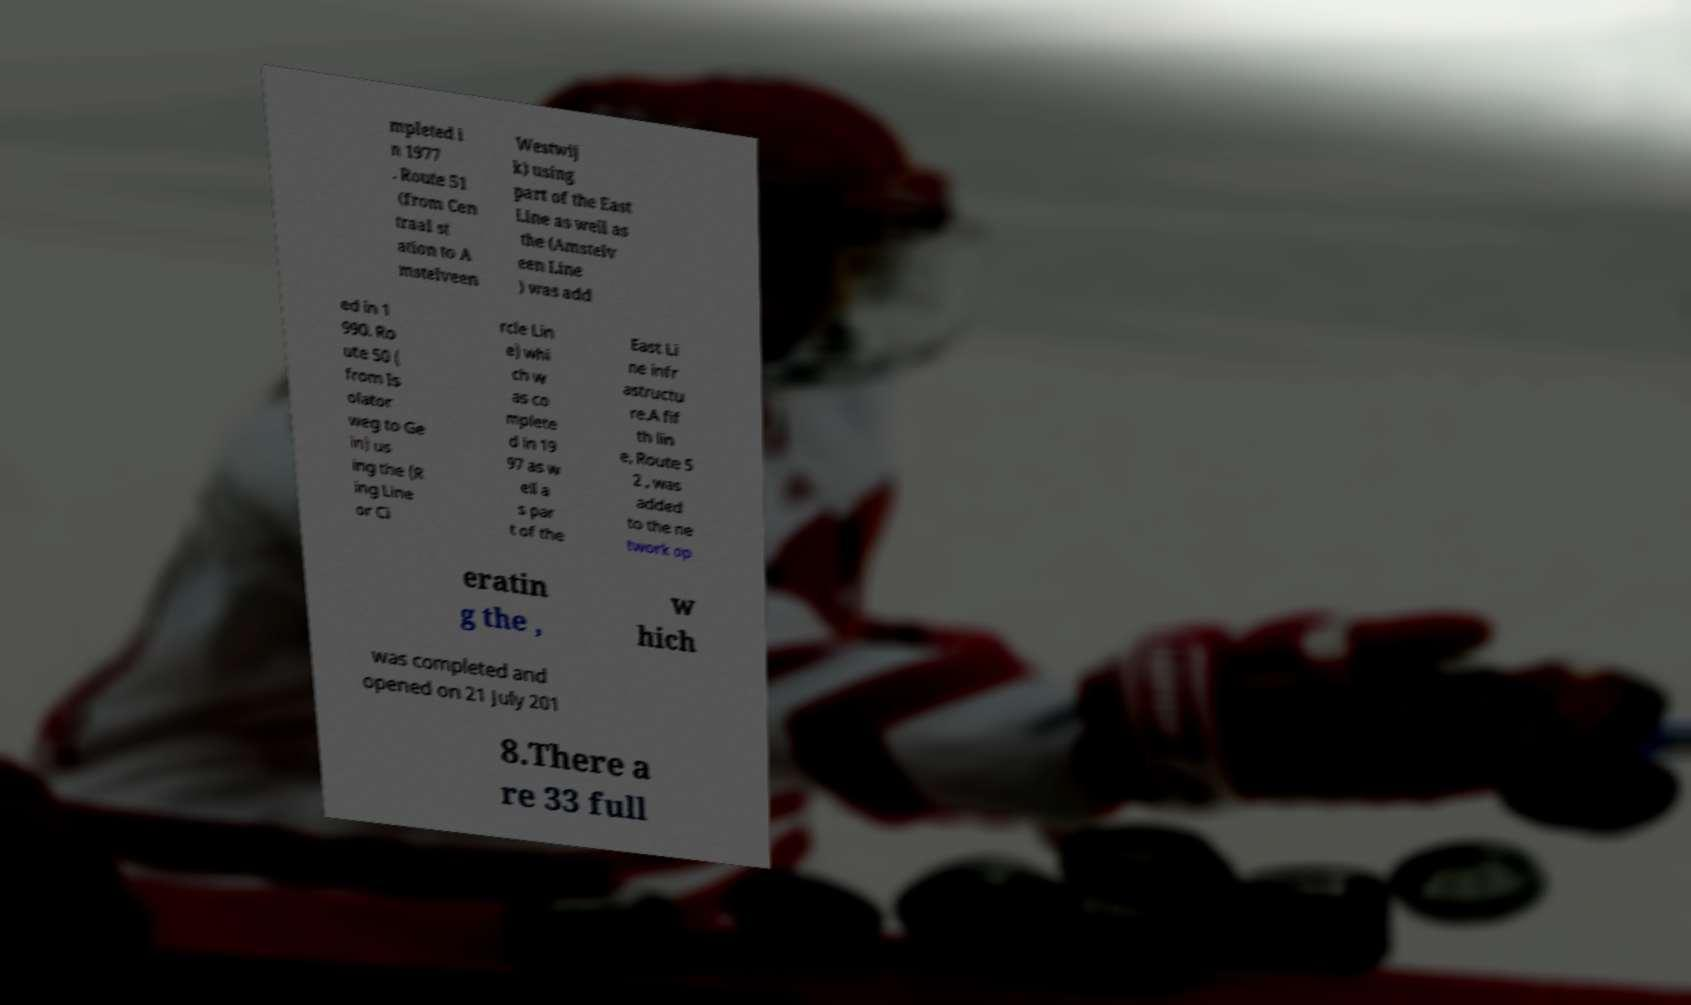I need the written content from this picture converted into text. Can you do that? mpleted i n 1977 . Route 51 (from Cen traal st ation to A mstelveen Westwij k) using part of the East Line as well as the (Amstelv een Line ) was add ed in 1 990. Ro ute 50 ( from Is olator weg to Ge in) us ing the (R ing Line or Ci rcle Lin e) whi ch w as co mplete d in 19 97 as w ell a s par t of the East Li ne infr astructu re.A fif th lin e, Route 5 2 , was added to the ne twork op eratin g the , w hich was completed and opened on 21 July 201 8.There a re 33 full 